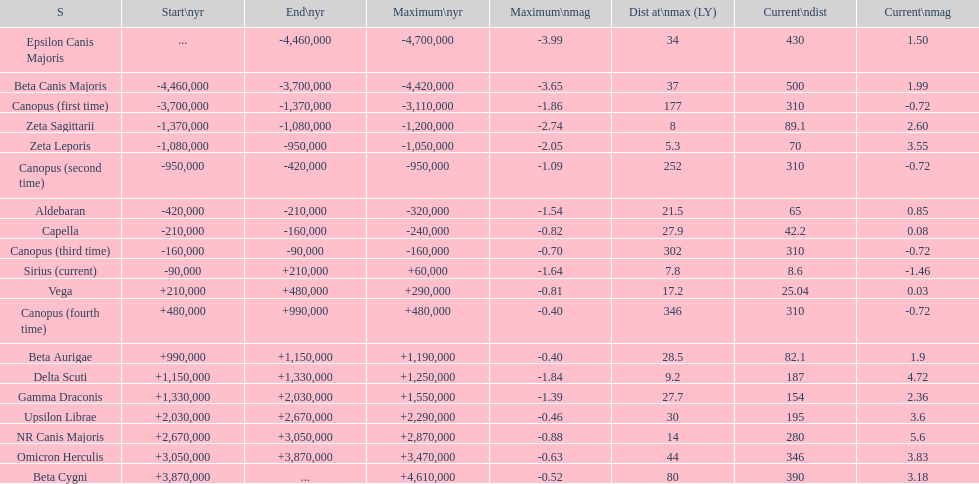Would you mind parsing the complete table? {'header': ['S', 'Start\\nyr', 'End\\nyr', 'Maximum\\nyr', 'Maximum\\nmag', 'Dist at\\nmax (LY)', 'Current\\ndist', 'Current\\nmag'], 'rows': [['Epsilon Canis Majoris', '...', '-4,460,000', '-4,700,000', '-3.99', '34', '430', '1.50'], ['Beta Canis Majoris', '-4,460,000', '-3,700,000', '-4,420,000', '-3.65', '37', '500', '1.99'], ['Canopus (first time)', '-3,700,000', '-1,370,000', '-3,110,000', '-1.86', '177', '310', '-0.72'], ['Zeta Sagittarii', '-1,370,000', '-1,080,000', '-1,200,000', '-2.74', '8', '89.1', '2.60'], ['Zeta Leporis', '-1,080,000', '-950,000', '-1,050,000', '-2.05', '5.3', '70', '3.55'], ['Canopus (second time)', '-950,000', '-420,000', '-950,000', '-1.09', '252', '310', '-0.72'], ['Aldebaran', '-420,000', '-210,000', '-320,000', '-1.54', '21.5', '65', '0.85'], ['Capella', '-210,000', '-160,000', '-240,000', '-0.82', '27.9', '42.2', '0.08'], ['Canopus (third time)', '-160,000', '-90,000', '-160,000', '-0.70', '302', '310', '-0.72'], ['Sirius (current)', '-90,000', '+210,000', '+60,000', '-1.64', '7.8', '8.6', '-1.46'], ['Vega', '+210,000', '+480,000', '+290,000', '-0.81', '17.2', '25.04', '0.03'], ['Canopus (fourth time)', '+480,000', '+990,000', '+480,000', '-0.40', '346', '310', '-0.72'], ['Beta Aurigae', '+990,000', '+1,150,000', '+1,190,000', '-0.40', '28.5', '82.1', '1.9'], ['Delta Scuti', '+1,150,000', '+1,330,000', '+1,250,000', '-1.84', '9.2', '187', '4.72'], ['Gamma Draconis', '+1,330,000', '+2,030,000', '+1,550,000', '-1.39', '27.7', '154', '2.36'], ['Upsilon Librae', '+2,030,000', '+2,670,000', '+2,290,000', '-0.46', '30', '195', '3.6'], ['NR Canis Majoris', '+2,670,000', '+3,050,000', '+2,870,000', '-0.88', '14', '280', '5.6'], ['Omicron Herculis', '+3,050,000', '+3,870,000', '+3,470,000', '-0.63', '44', '346', '3.83'], ['Beta Cygni', '+3,870,000', '...', '+4,610,000', '-0.52', '80', '390', '3.18']]} What is the only star with a distance at maximum of 80? Beta Cygni. 